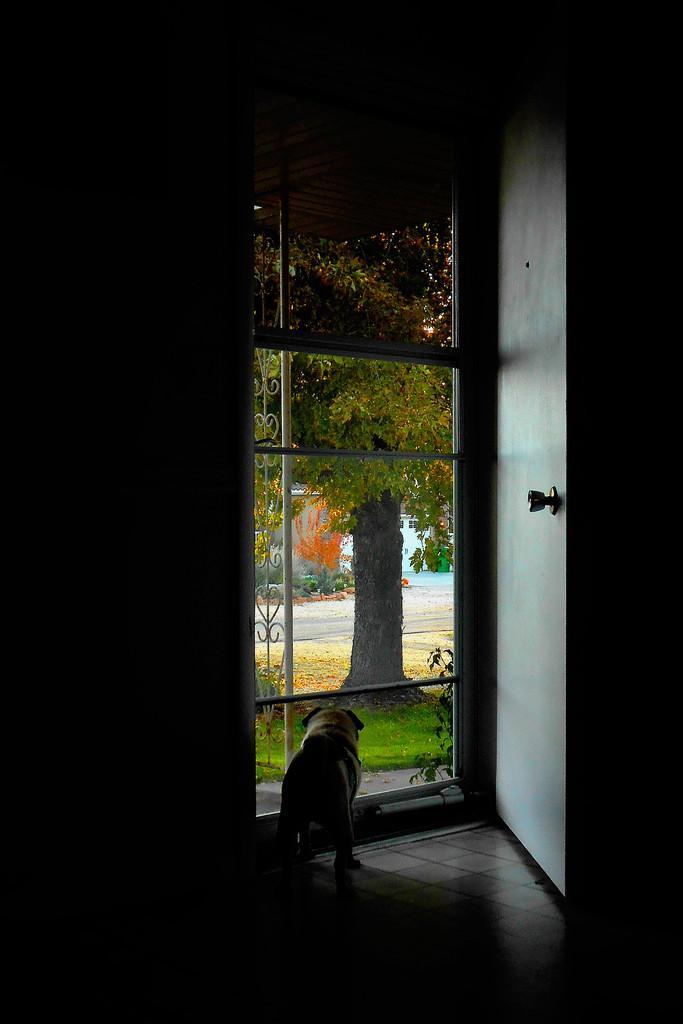Can you describe this image briefly? In this image we can see a dog on the floor beside a door. We can also see some grass, a tree, plants and some poles. 